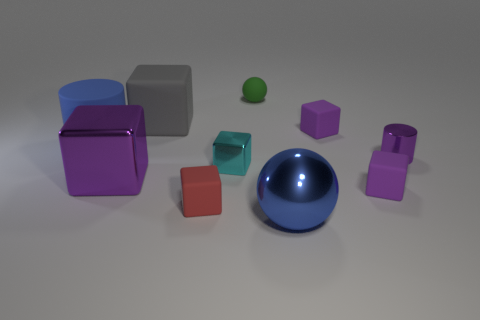How many objects are in front of the large, magenta cube? In front of the large magenta cube, there seem to be two objects: a small red cube and a medium-sized purple cube. 